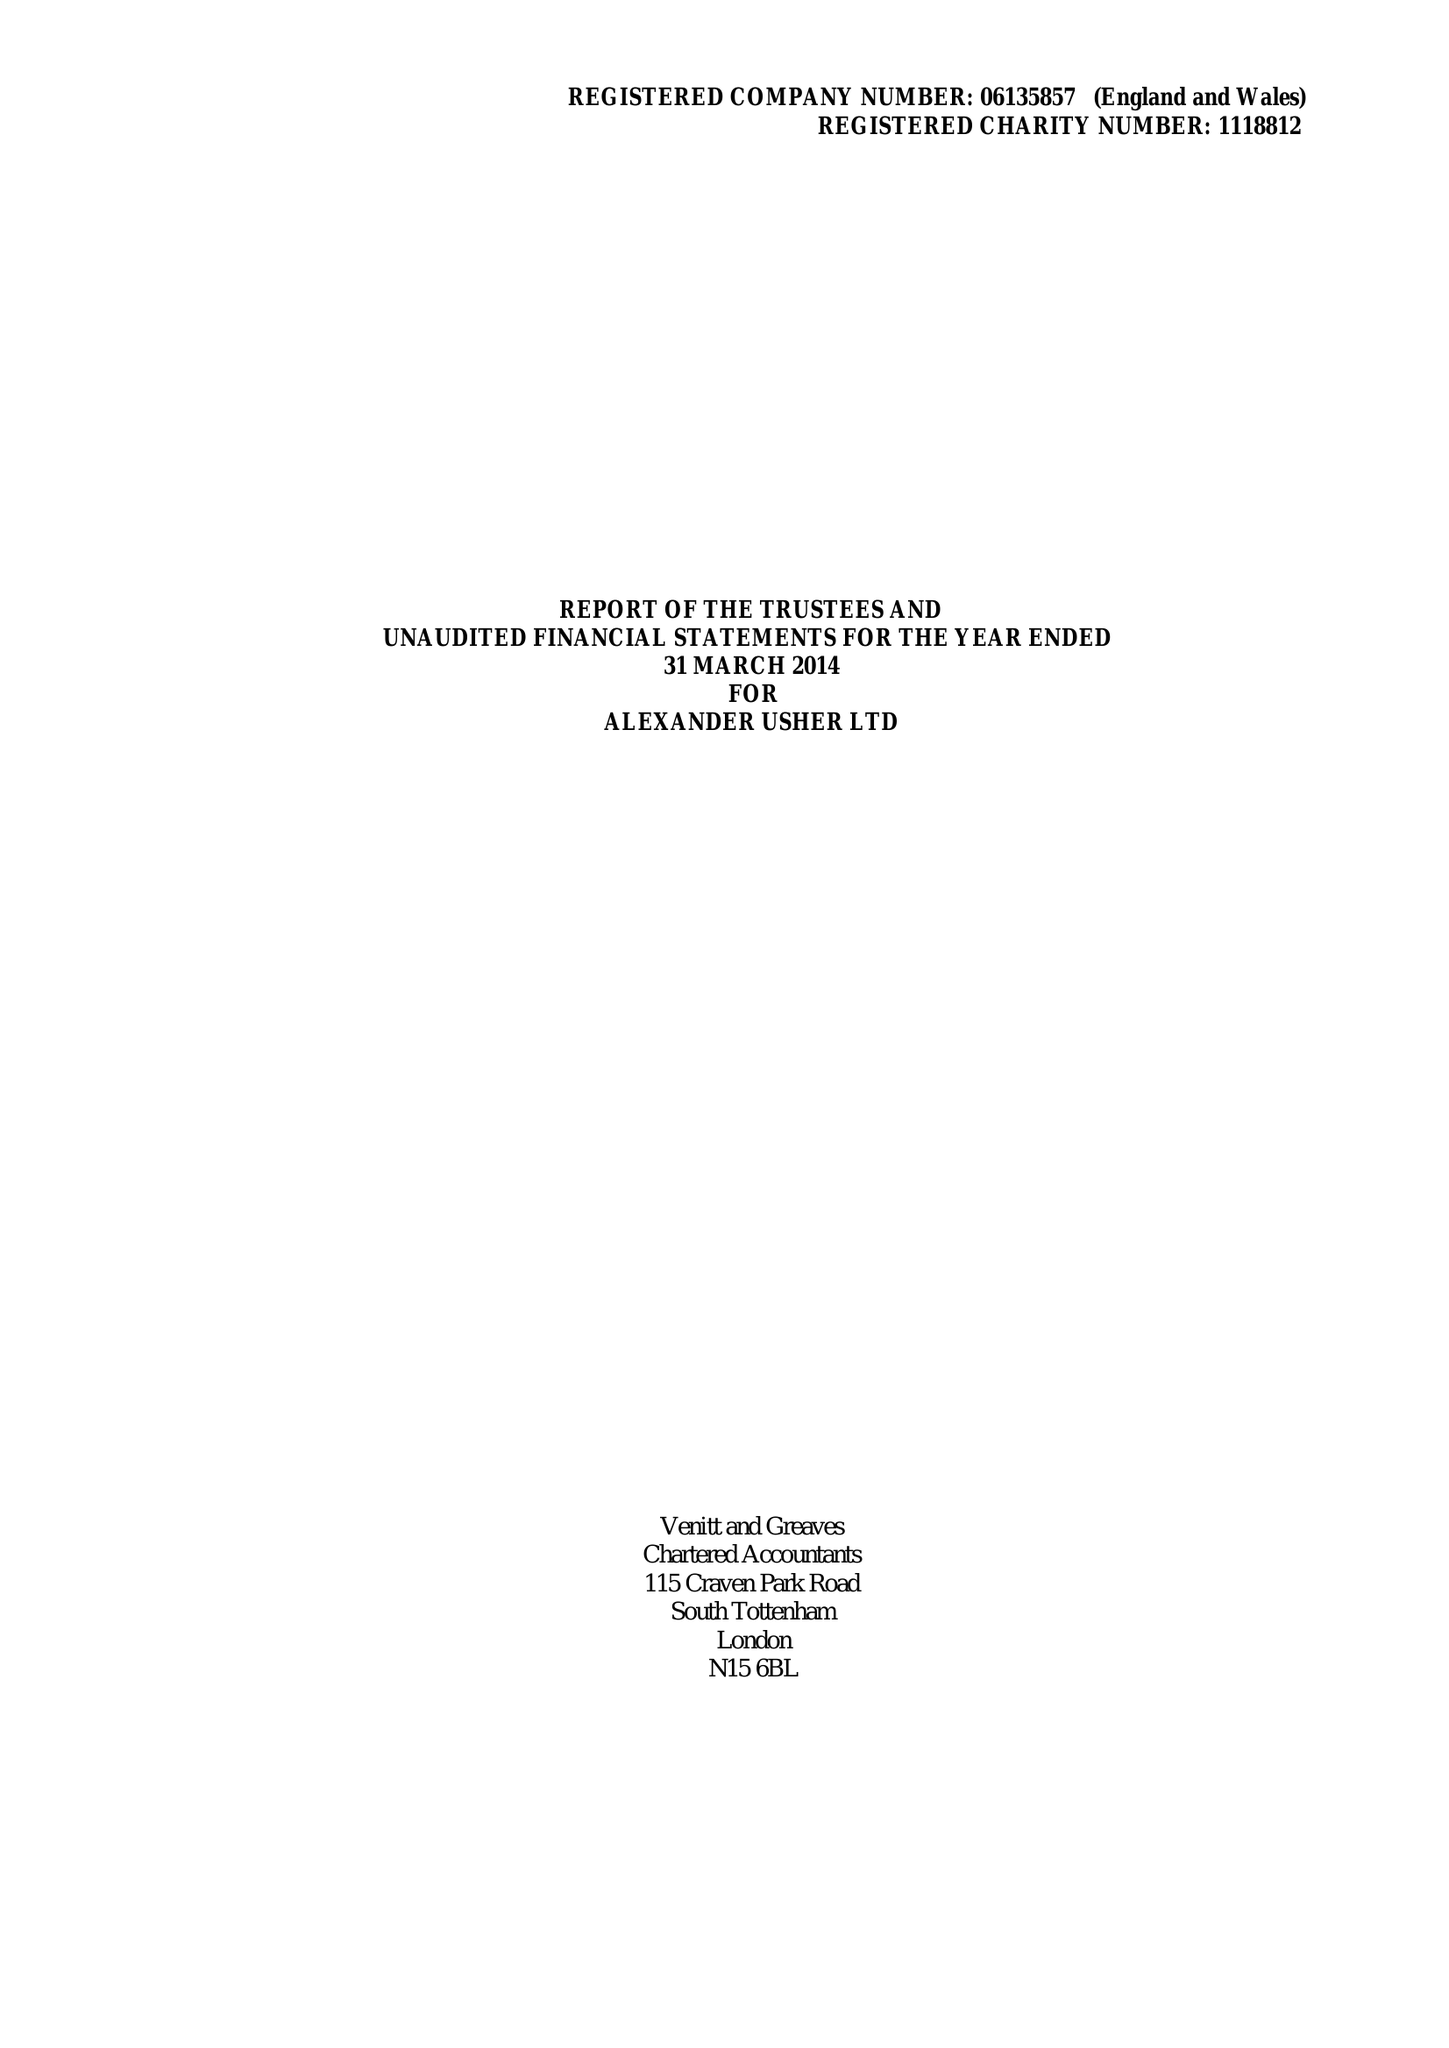What is the value for the address__street_line?
Answer the question using a single word or phrase. 115 CRAVEN PARK ROAD 